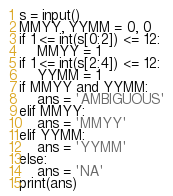Convert code to text. <code><loc_0><loc_0><loc_500><loc_500><_Python_>s = input()
MMYY, YYMM = 0, 0
if 1 <= int(s[0:2]) <= 12:
    MMYY = 1
if 1 <= int(s[2:4]) <= 12:
    YYMM = 1
if MMYY and YYMM:
    ans = 'AMBIGUOUS'
elif MMYY:
    ans = 'MMYY'
elif YYMM:
    ans = 'YYMM'
else:
    ans = 'NA'
print(ans)</code> 